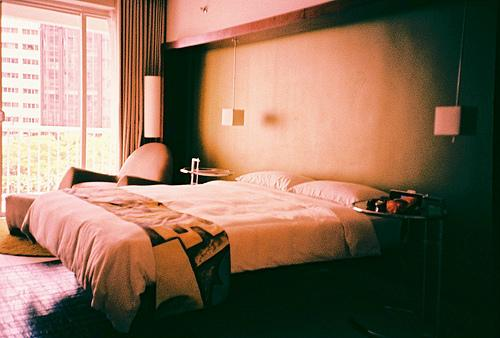Mention the key elements and their colors in the scene. The scene includes a large bed with white linens, white pillows, and a colorful blanket, a green floor rug, floor-to-ceiling curtains, a sliding glass door, and a hanging light with a cube-shaped shade. Describe the outdoor area visible through the sliding glass door. There is a fence or white railing on the balcony visible through the sliding glass door, suggesting an outdoor area that may be used for relaxation or viewing the surroundings. What type of bed is in the image and how is it decorated? The image shows a large bed with white linens, two white pillows, a folded white blanket, and another blanket with a colorful design, all placed neatly, making the bed appear well-made. Mention something unusual or unique about the curtains in the image. The floor-to-ceiling curtains in the image are open and pushed to one side, allowing light to enter the room through the glass door, and revealing pleats in the fabric. Describe the flooring and its accessories in the image. The floor features a small area rug and a round rug, both adding color and texture to the space. There is also a shadow of the bed on the floor, indicating that light is streaming into the room. Describe one object in the image with its color and location. There is a rectangular alarm clock in the room, placed on a modern bedside table, to the right side of the bed. The clock appears to be white or silver. What kind of room is depicted in the image and what are some notable features? The image shows a bedroom featuring a bed with no headboard, hanging lights, a sliding glass door, an armchair, and various other furniture pieces like side tables and lamps. Identify an item related to light in the image and describe its characteristics. There is a hanging light fixture with a white cube-shaped shade suspended from a pole in the room. It adds an elegant and modern touch to the space. What piece of furniture can you find next to the bed and how would you describe its style? There is a modern bedside table with a sleek design on the right side of the bed. It holds an alarm clock and is accompanied by a floor-to-ceiling curtain on the other side. What type of chair is visible in the image and where is it located? A comfortable armchair with two arms is located in front of the window on the left side of the room, next to the sliding glass door. 